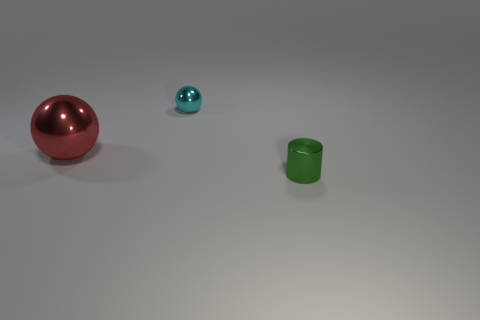There is another shiny thing that is the same shape as the big red object; what color is it?
Provide a short and direct response. Cyan. Is there anything else that is the same color as the big sphere?
Offer a very short reply. No. Is the number of tiny blue things greater than the number of small cyan things?
Your answer should be very brief. No. Do the large object and the tiny sphere have the same material?
Offer a very short reply. Yes. What number of other cyan spheres are the same material as the small sphere?
Give a very brief answer. 0. Does the red metallic thing have the same size as the metal thing that is to the right of the tiny cyan sphere?
Keep it short and to the point. No. What is the color of the object that is in front of the tiny cyan object and on the right side of the large metal object?
Make the answer very short. Green. There is a metallic object in front of the red ball; are there any large red metal balls behind it?
Provide a succinct answer. Yes. Are there an equal number of green metal cylinders that are on the left side of the cyan metal thing and small red cylinders?
Give a very brief answer. Yes. What number of big red spheres are on the right side of the tiny object on the right side of the object behind the large shiny thing?
Your answer should be very brief. 0. 